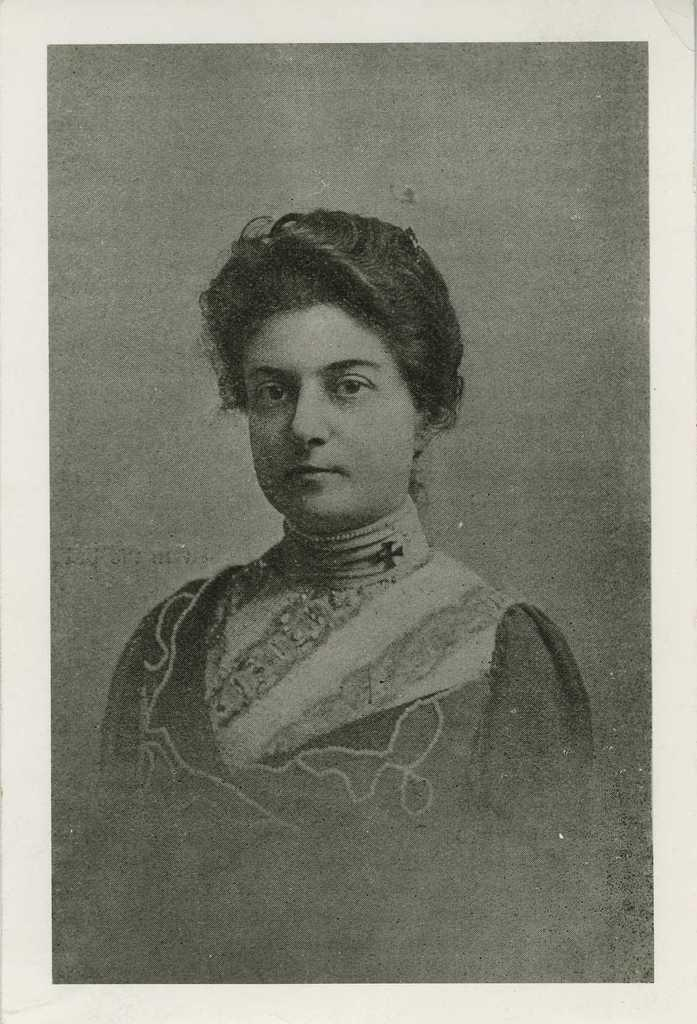What object is present in the image that typically holds a photograph? There is a photo frame in the image. What can be seen inside the photo frame? The photo frame contains an image of a person. What color scheme is used for the image inside the photo frame? The image is black and white. What type of metal is used to create the soap in the image? There is no soap or metal present in the image; it features a photo frame with a black and white image of a person. 